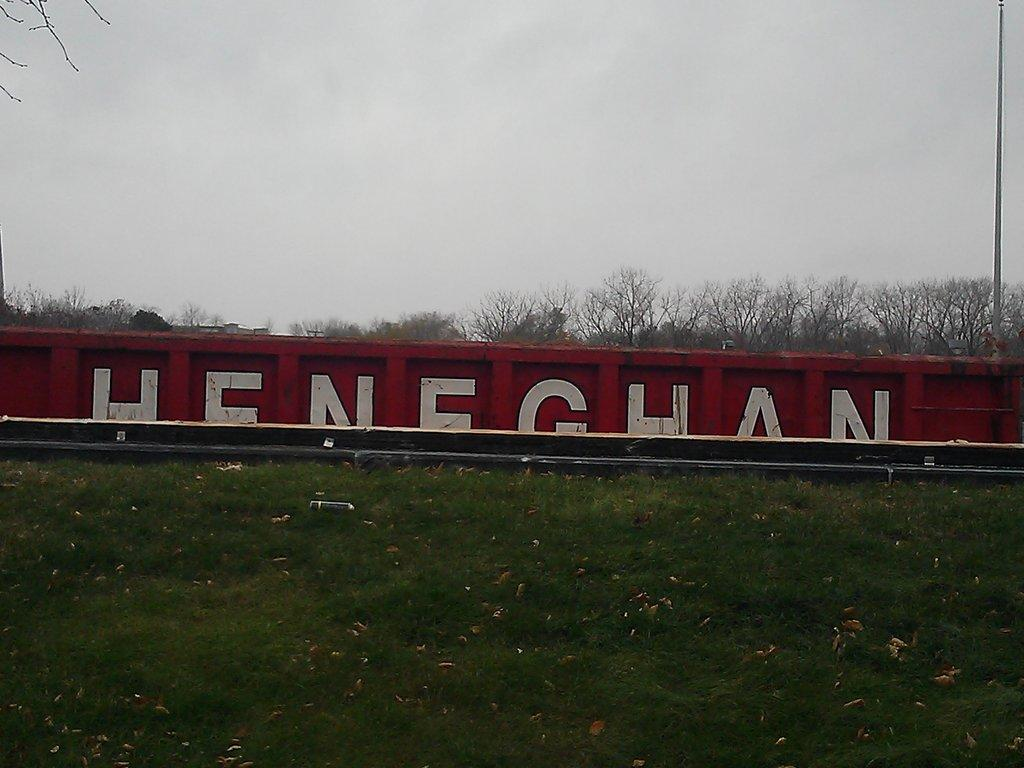Provide a one-sentence caption for the provided image. The letters HENEGHAN are able to be about half seen painted on a fence or train car hidden by a grassy hill. 